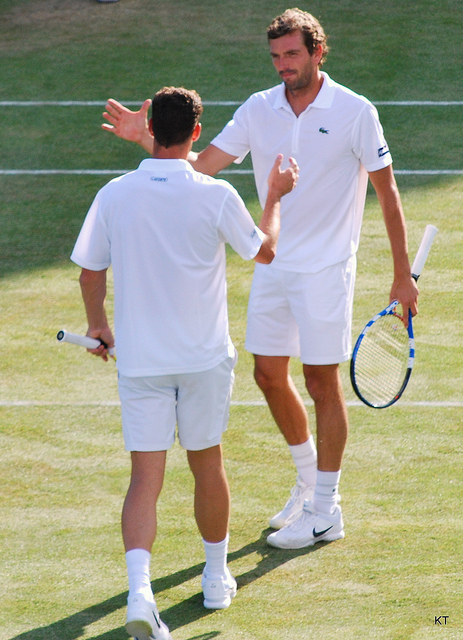Please identify all text content in this image. KT 